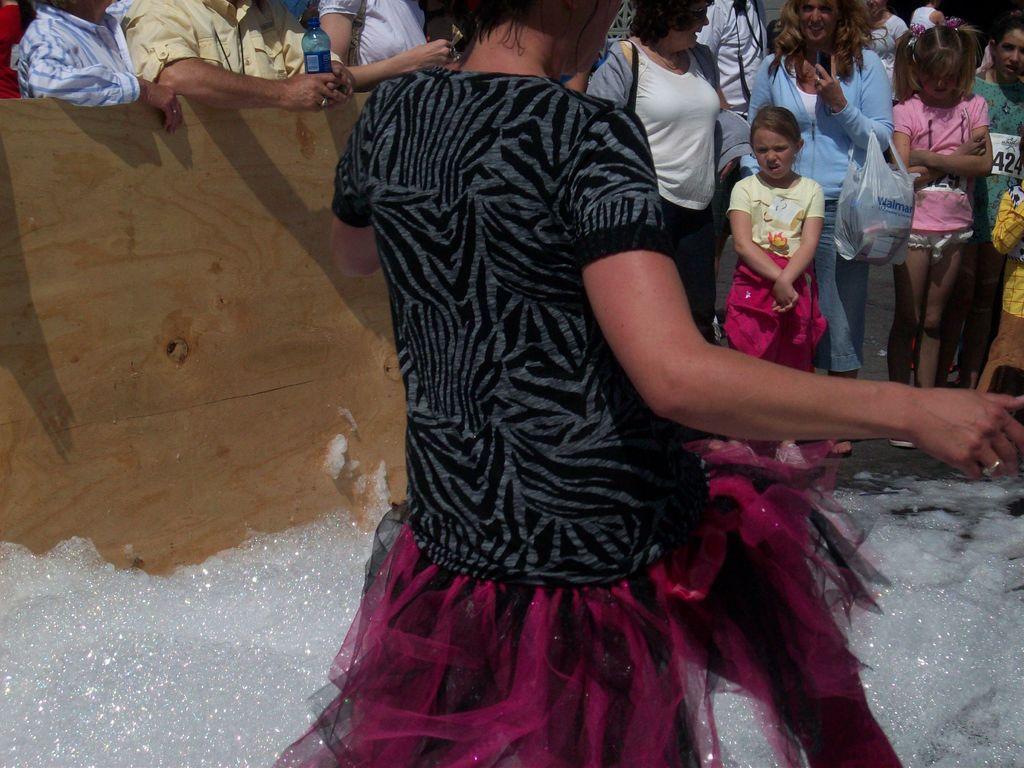Could you give a brief overview of what you see in this image? In this picture, it looks like a foam and some people are standing on the road. A woman is holding an object and a person is holding a bottle. In front of the people there is a wooden sheet. 